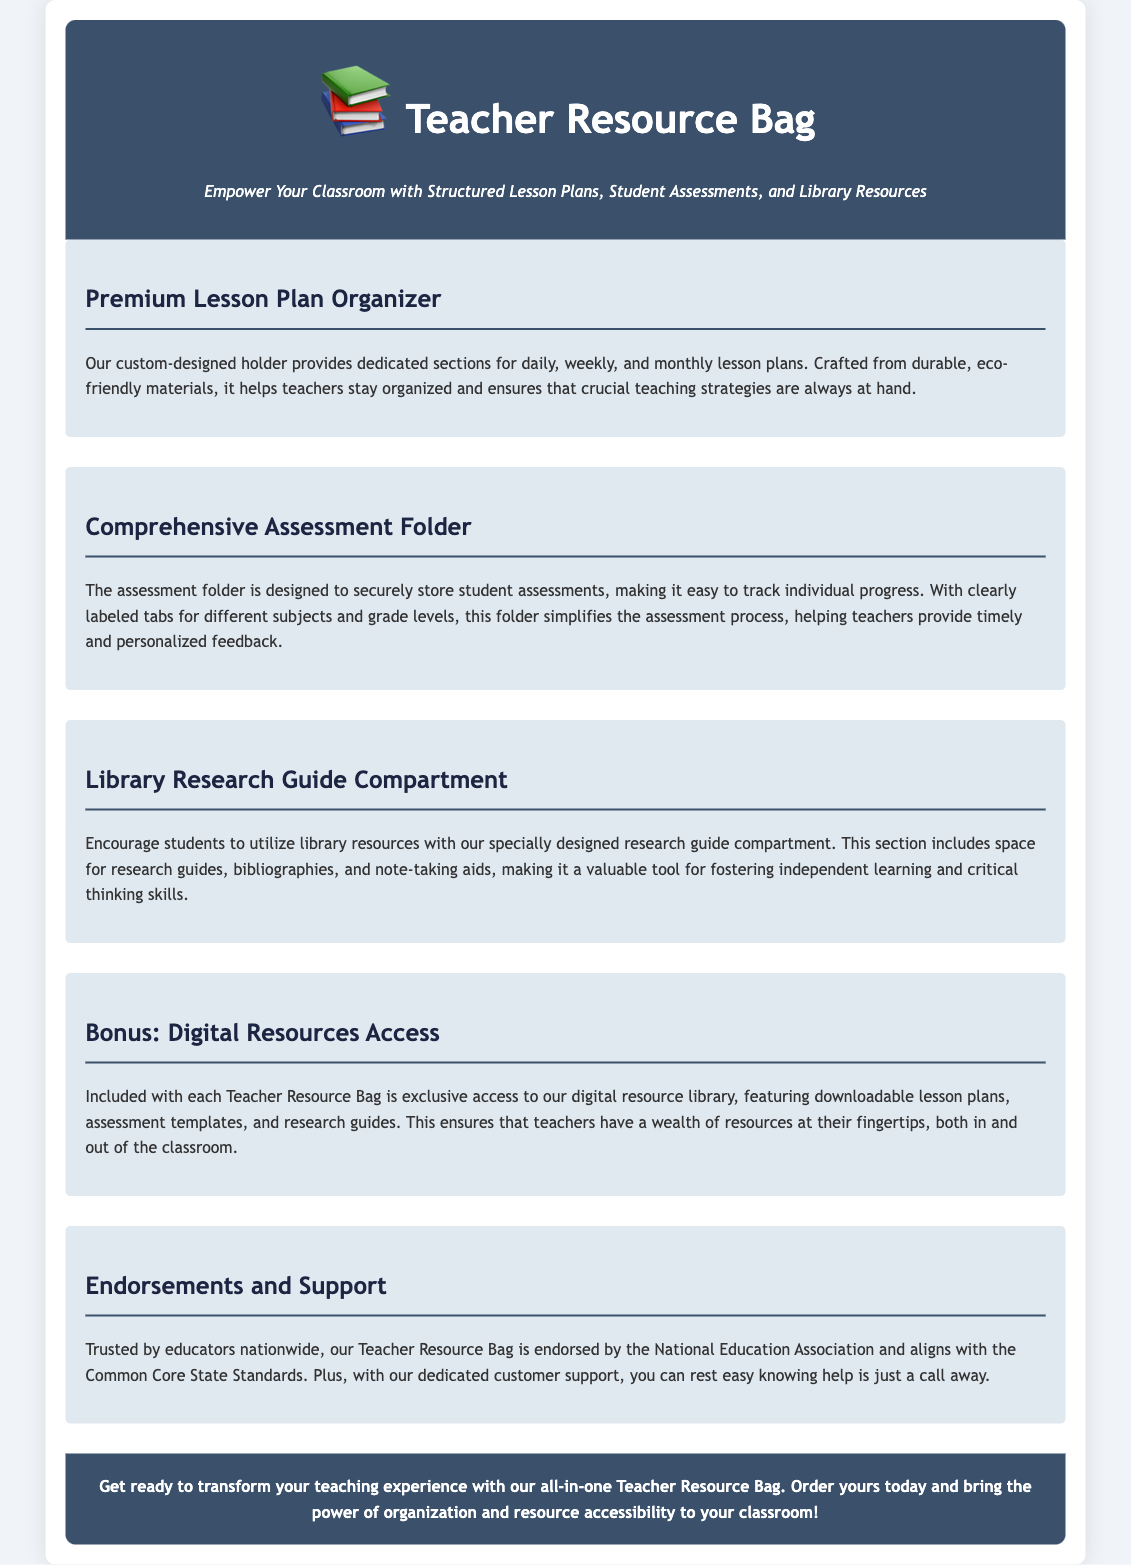What is the title of the document? The title is prominently displayed at the top of the document, providing clear identification of the content.
Answer: Teacher Resource Bag: A Comprehensive Tool for Educators What icon is used in the header? The header features an emoji that symbolizes the document's focus on educational resources.
Answer: 📚 How many sections are included in the product description? The document outlines several distinct parts that provide details about different features of the Teacher Resource Bag.
Answer: Five What does the Premium Lesson Plan Organizer hold? This section specifically details what the organizer is designed to manage regarding educational materials.
Answer: Lesson plans Who endorses the Teacher Resource Bag? The document states which organization supports and endorses the effectiveness of the bag for educators.
Answer: National Education Association What type of materials are used for the lesson plan organizer? The document specifies the quality and environmental consideration of the materials used in the product's design.
Answer: Eco-friendly materials What bonus comes with the Teacher Resource Bag? This question highlights the extra feature that adds value to the product, enhancing its usability.
Answer: Digital resources access Why is the Library Research Guide Compartment valuable? The document explains the purpose of this compartment in improving student skills through resource utilization.
Answer: Fostering independent learning 